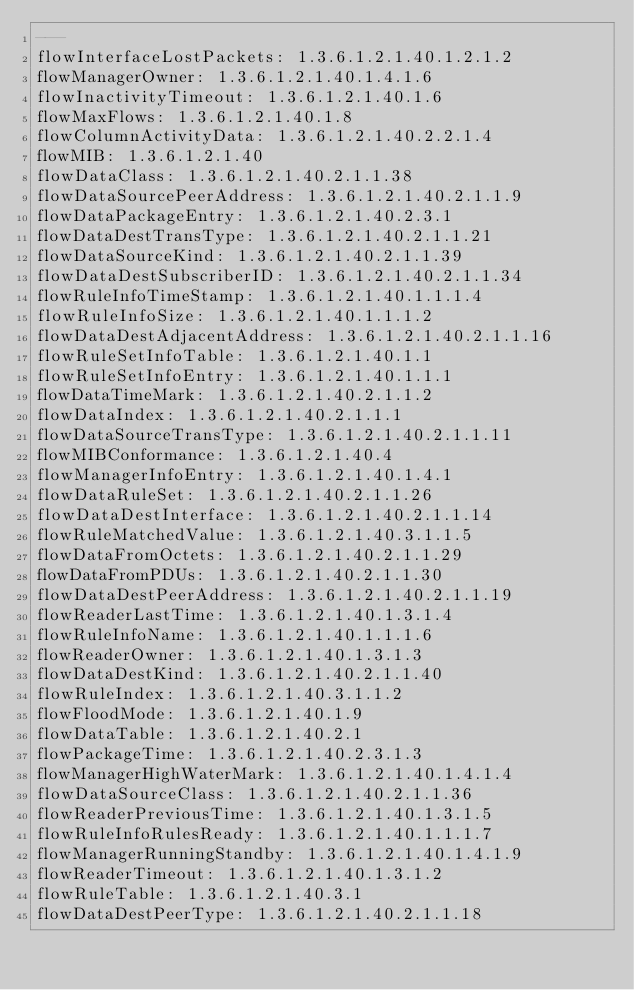Convert code to text. <code><loc_0><loc_0><loc_500><loc_500><_YAML_>--- 
flowInterfaceLostPackets: 1.3.6.1.2.1.40.1.2.1.2
flowManagerOwner: 1.3.6.1.2.1.40.1.4.1.6
flowInactivityTimeout: 1.3.6.1.2.1.40.1.6
flowMaxFlows: 1.3.6.1.2.1.40.1.8
flowColumnActivityData: 1.3.6.1.2.1.40.2.2.1.4
flowMIB: 1.3.6.1.2.1.40
flowDataClass: 1.3.6.1.2.1.40.2.1.1.38
flowDataSourcePeerAddress: 1.3.6.1.2.1.40.2.1.1.9
flowDataPackageEntry: 1.3.6.1.2.1.40.2.3.1
flowDataDestTransType: 1.3.6.1.2.1.40.2.1.1.21
flowDataSourceKind: 1.3.6.1.2.1.40.2.1.1.39
flowDataDestSubscriberID: 1.3.6.1.2.1.40.2.1.1.34
flowRuleInfoTimeStamp: 1.3.6.1.2.1.40.1.1.1.4
flowRuleInfoSize: 1.3.6.1.2.1.40.1.1.1.2
flowDataDestAdjacentAddress: 1.3.6.1.2.1.40.2.1.1.16
flowRuleSetInfoTable: 1.3.6.1.2.1.40.1.1
flowRuleSetInfoEntry: 1.3.6.1.2.1.40.1.1.1
flowDataTimeMark: 1.3.6.1.2.1.40.2.1.1.2
flowDataIndex: 1.3.6.1.2.1.40.2.1.1.1
flowDataSourceTransType: 1.3.6.1.2.1.40.2.1.1.11
flowMIBConformance: 1.3.6.1.2.1.40.4
flowManagerInfoEntry: 1.3.6.1.2.1.40.1.4.1
flowDataRuleSet: 1.3.6.1.2.1.40.2.1.1.26
flowDataDestInterface: 1.3.6.1.2.1.40.2.1.1.14
flowRuleMatchedValue: 1.3.6.1.2.1.40.3.1.1.5
flowDataFromOctets: 1.3.6.1.2.1.40.2.1.1.29
flowDataFromPDUs: 1.3.6.1.2.1.40.2.1.1.30
flowDataDestPeerAddress: 1.3.6.1.2.1.40.2.1.1.19
flowReaderLastTime: 1.3.6.1.2.1.40.1.3.1.4
flowRuleInfoName: 1.3.6.1.2.1.40.1.1.1.6
flowReaderOwner: 1.3.6.1.2.1.40.1.3.1.3
flowDataDestKind: 1.3.6.1.2.1.40.2.1.1.40
flowRuleIndex: 1.3.6.1.2.1.40.3.1.1.2
flowFloodMode: 1.3.6.1.2.1.40.1.9
flowDataTable: 1.3.6.1.2.1.40.2.1
flowPackageTime: 1.3.6.1.2.1.40.2.3.1.3
flowManagerHighWaterMark: 1.3.6.1.2.1.40.1.4.1.4
flowDataSourceClass: 1.3.6.1.2.1.40.2.1.1.36
flowReaderPreviousTime: 1.3.6.1.2.1.40.1.3.1.5
flowRuleInfoRulesReady: 1.3.6.1.2.1.40.1.1.1.7
flowManagerRunningStandby: 1.3.6.1.2.1.40.1.4.1.9
flowReaderTimeout: 1.3.6.1.2.1.40.1.3.1.2
flowRuleTable: 1.3.6.1.2.1.40.3.1
flowDataDestPeerType: 1.3.6.1.2.1.40.2.1.1.18</code> 